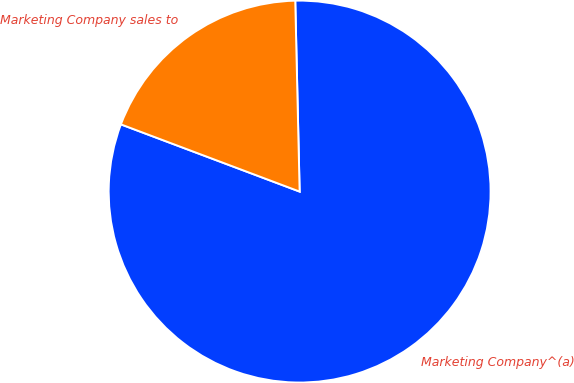<chart> <loc_0><loc_0><loc_500><loc_500><pie_chart><fcel>Marketing Company^(a)<fcel>Marketing Company sales to<nl><fcel>81.09%<fcel>18.91%<nl></chart> 